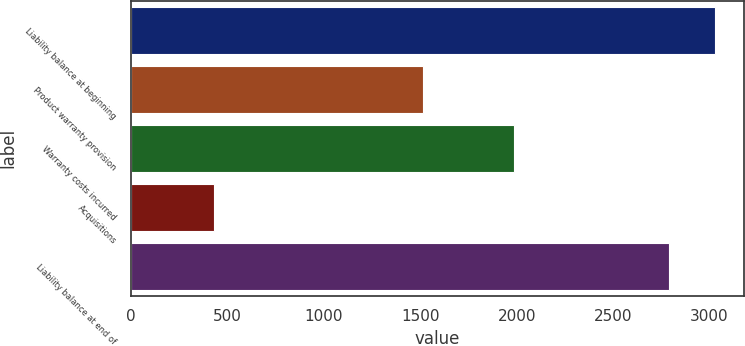<chart> <loc_0><loc_0><loc_500><loc_500><bar_chart><fcel>Liability balance at beginning<fcel>Product warranty provision<fcel>Warranty costs incurred<fcel>Acquisitions<fcel>Liability balance at end of<nl><fcel>3028.6<fcel>1512<fcel>1985<fcel>433<fcel>2789<nl></chart> 